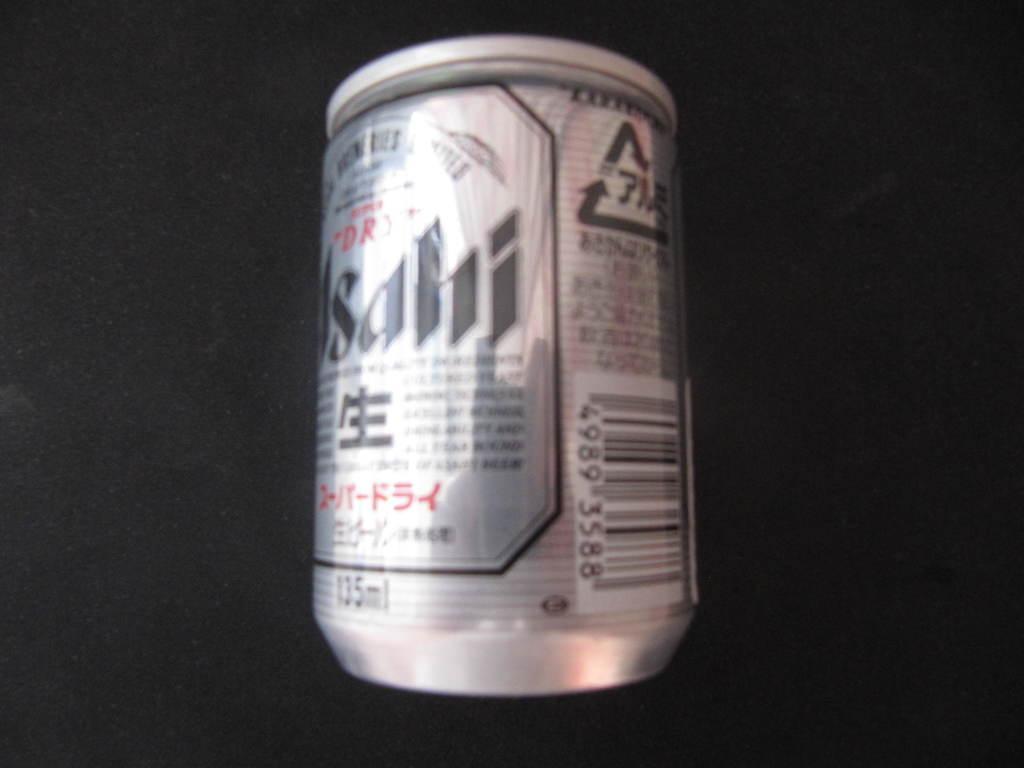Could you give a brief overview of what you see in this image? In this picture we can see a tin on a black surface. 